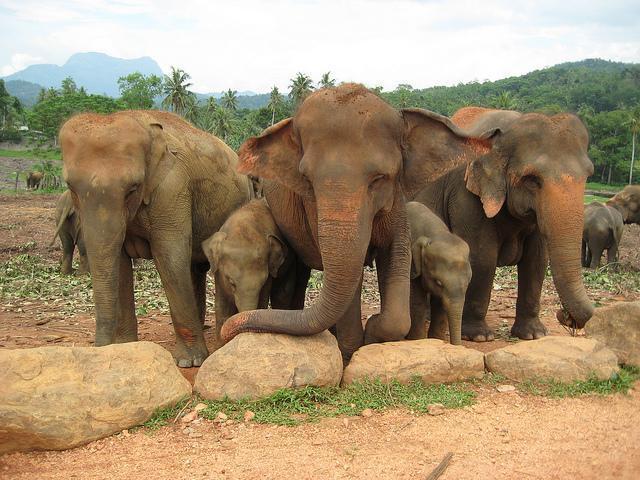How many elephants are there?
Give a very brief answer. 6. How many chairs at near the window?
Give a very brief answer. 0. 